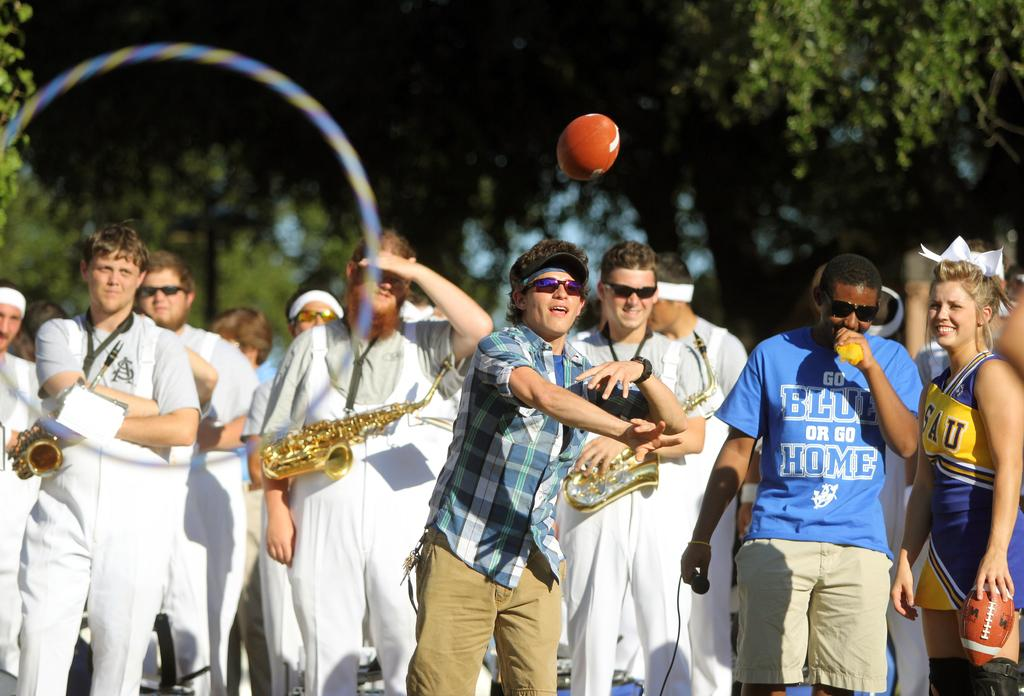<image>
Provide a brief description of the given image. A black man in a go blue or go home shirt stands next to a person throwing a football. 